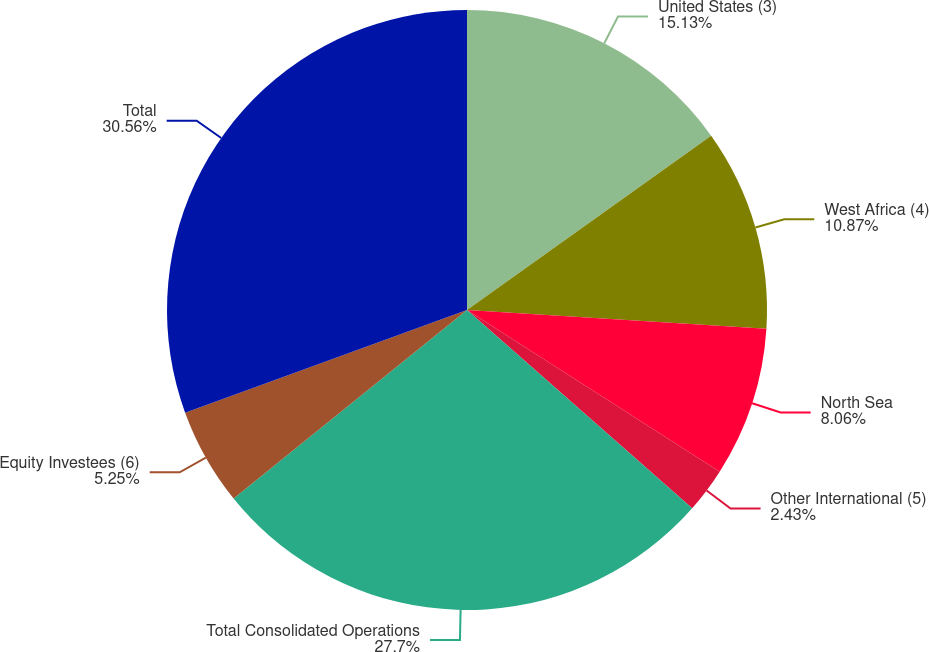Convert chart. <chart><loc_0><loc_0><loc_500><loc_500><pie_chart><fcel>United States (3)<fcel>West Africa (4)<fcel>North Sea<fcel>Other International (5)<fcel>Total Consolidated Operations<fcel>Equity Investees (6)<fcel>Total<nl><fcel>15.13%<fcel>10.87%<fcel>8.06%<fcel>2.43%<fcel>27.7%<fcel>5.25%<fcel>30.56%<nl></chart> 